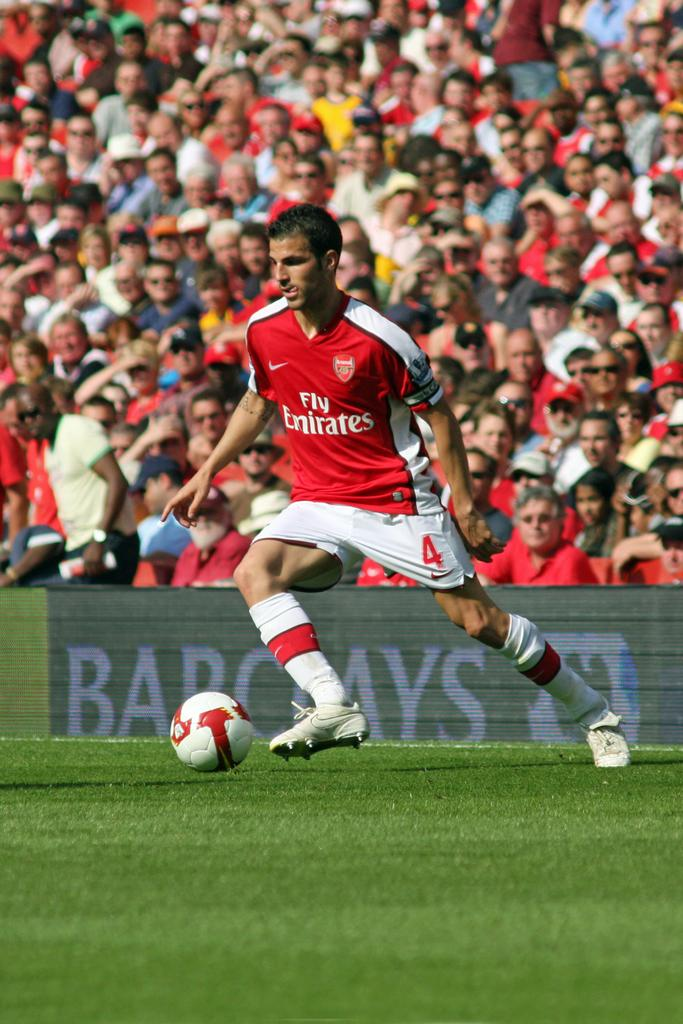What type of terrain is visible in the image? The land is covered with grass. What object is in front of the person? There is a ball in front of a person. Can you describe the people in the image? There are people in the audience. What is the aftermath of the battle in the image? There is no battle or aftermath present in the image; it features a person with a ball and people in the audience. How many numbers are visible in the image? There are no numbers visible in the image. 